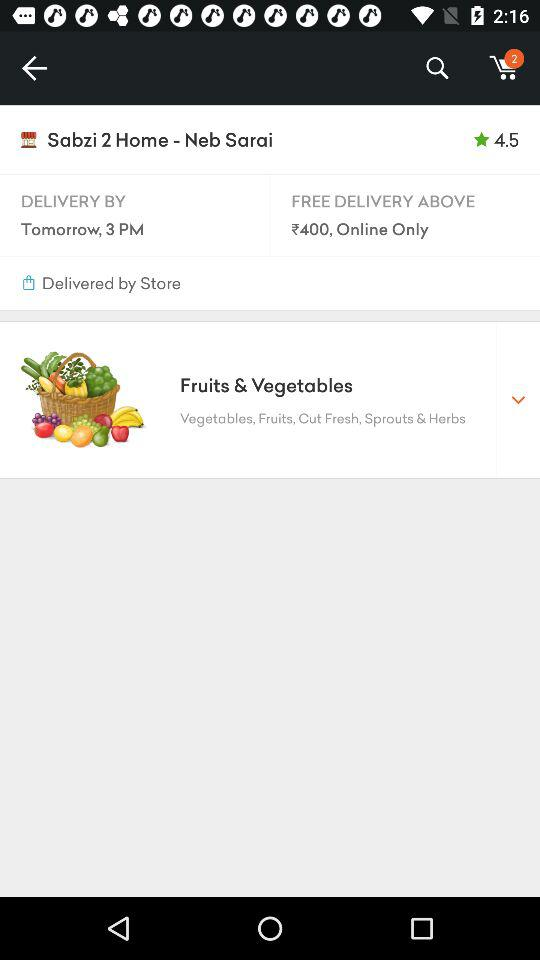What is the rating of "Sabzi 2 Home - Neb Sarai"? The rating is 4.5. 